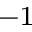<formula> <loc_0><loc_0><loc_500><loc_500>^ { - 1 }</formula> 